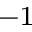<formula> <loc_0><loc_0><loc_500><loc_500>^ { - 1 }</formula> 